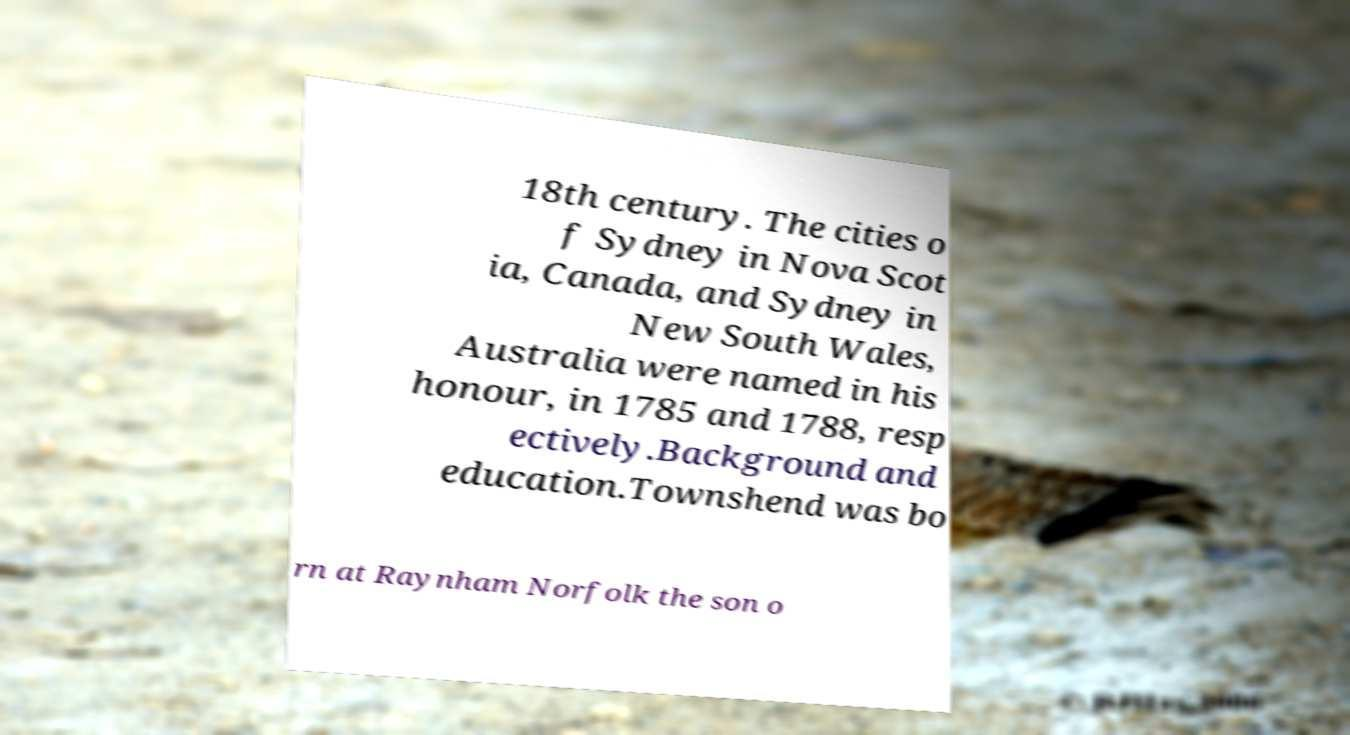Can you read and provide the text displayed in the image?This photo seems to have some interesting text. Can you extract and type it out for me? 18th century. The cities o f Sydney in Nova Scot ia, Canada, and Sydney in New South Wales, Australia were named in his honour, in 1785 and 1788, resp ectively.Background and education.Townshend was bo rn at Raynham Norfolk the son o 